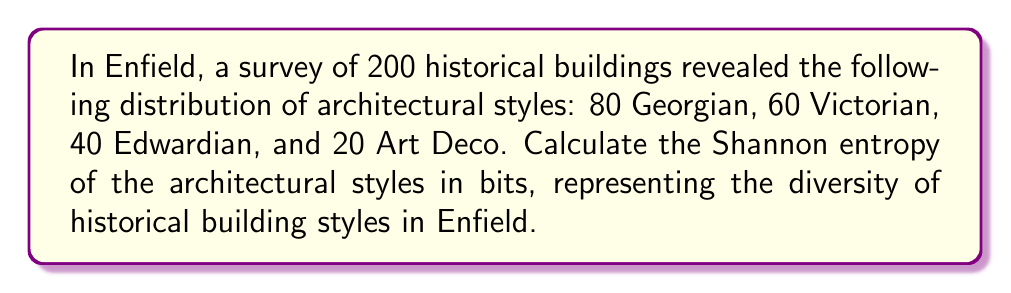Give your solution to this math problem. To calculate the Shannon entropy of the architectural styles in Enfield, we'll follow these steps:

1. Calculate the probability of each architectural style:
   $p(\text{Georgian}) = 80/200 = 0.4$
   $p(\text{Victorian}) = 60/200 = 0.3$
   $p(\text{Edwardian}) = 40/200 = 0.2$
   $p(\text{Art Deco}) = 20/200 = 0.1$

2. Apply the Shannon entropy formula:
   $$H = -\sum_{i=1}^{n} p_i \log_2(p_i)$$
   where $H$ is the Shannon entropy, $p_i$ is the probability of each style, and $n$ is the number of styles.

3. Calculate each term:
   $-0.4 \log_2(0.4) \approx 0.5288$
   $-0.3 \log_2(0.3) \approx 0.5211$
   $-0.2 \log_2(0.2) \approx 0.4644$
   $-0.1 \log_2(0.1) \approx 0.3322$

4. Sum up all terms:
   $H = 0.5288 + 0.5211 + 0.4644 + 0.3322 = 1.8465$ bits

The Shannon entropy represents the average amount of information conveyed by identifying the architectural style of a randomly chosen building in Enfield. A higher value indicates greater diversity in architectural styles.
Answer: The Shannon entropy of architectural styles in Enfield is approximately 1.8465 bits. 